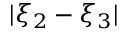<formula> <loc_0><loc_0><loc_500><loc_500>| \xi _ { 2 } - \xi _ { 3 } |</formula> 